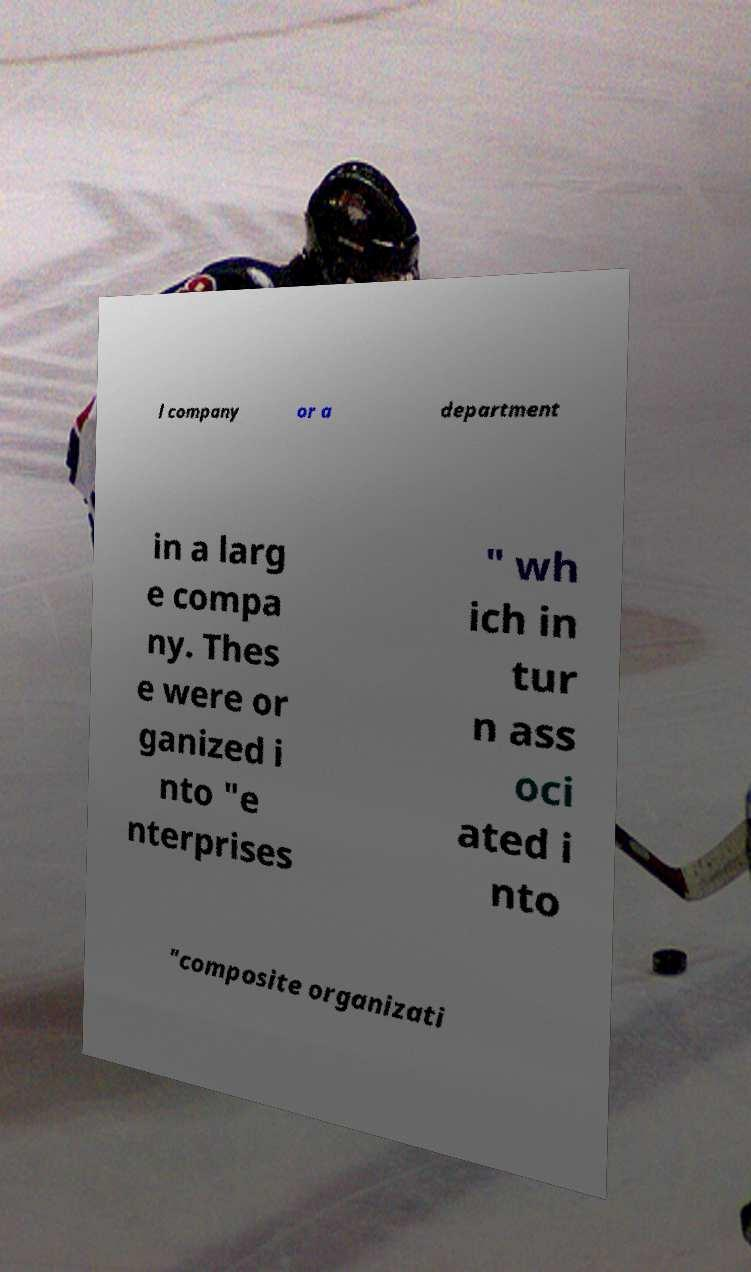Can you accurately transcribe the text from the provided image for me? l company or a department in a larg e compa ny. Thes e were or ganized i nto "e nterprises " wh ich in tur n ass oci ated i nto "composite organizati 